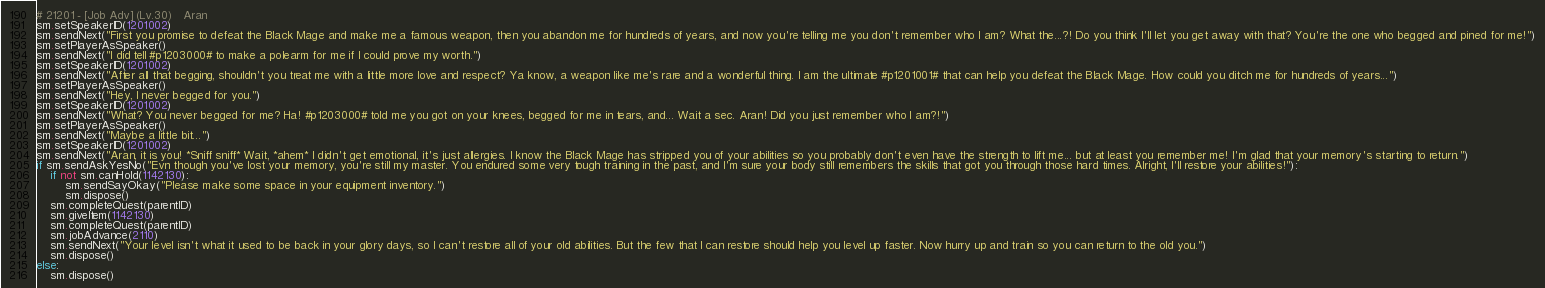<code> <loc_0><loc_0><loc_500><loc_500><_Python_># 21201 - [Job Adv] (Lv.30)   Aran
sm.setSpeakerID(1201002)
sm.sendNext("First you promise to defeat the Black Mage and make me a famous weapon, then you abandon me for hundreds of years, and now you're telling me you don't remember who I am? What the...?! Do you think I'll let you get away with that? You're the one who begged and pined for me!")
sm.setPlayerAsSpeaker()
sm.sendNext("I did tell #p1203000# to make a polearm for me if I could prove my worth.")
sm.setSpeakerID(1201002)
sm.sendNext("After all that begging, shouldn't you treat me with a little more love and respect? Ya know, a weapon like me's rare and a wonderful thing. I am the ultimate #p1201001# that can help you defeat the Black Mage. How could you ditch me for hundreds of years...")
sm.setPlayerAsSpeaker()
sm.sendNext("Hey, I never begged for you.")
sm.setSpeakerID(1201002)
sm.sendNext("What? You never begged for me? Ha! #p1203000# told me you got on your knees, begged for me in tears, and... Wait a sec. Aran! Did you just remember who I am?!")
sm.setPlayerAsSpeaker()
sm.sendNext("Maybe a little bit...")
sm.setSpeakerID(1201002)
sm.sendNext("Aran, it is you! *Sniff sniff* Wait, *ahem* I didn't get emotional, it's just allergies. I know the Black Mage has stripped you of your abilities so you probably don't even have the strength to lift me... but at least you remember me! I'm glad that your memory's starting to return.")
if sm.sendAskYesNo("Evn though you've lost your memory, you're still my master. You endured some very tough training in the past, and I'm sure your body still remembers the skills that got you through those hard times. Alright, I'll restore your abilities!"):
    if not sm.canHold(1142130):
        sm.sendSayOkay("Please make some space in your equipment inventory.")
        sm.dispose()
    sm.completeQuest(parentID)
    sm.giveItem(1142130)
    sm.completeQuest(parentID)
    sm.jobAdvance(2110)
    sm.sendNext("Your level isn't what it used to be back in your glory days, so I can't restore all of your old abilities. But the few that I can restore should help you level up faster. Now hurry up and train so you can return to the old you.")
    sm.dispose()
else:
    sm.dispose()
</code> 